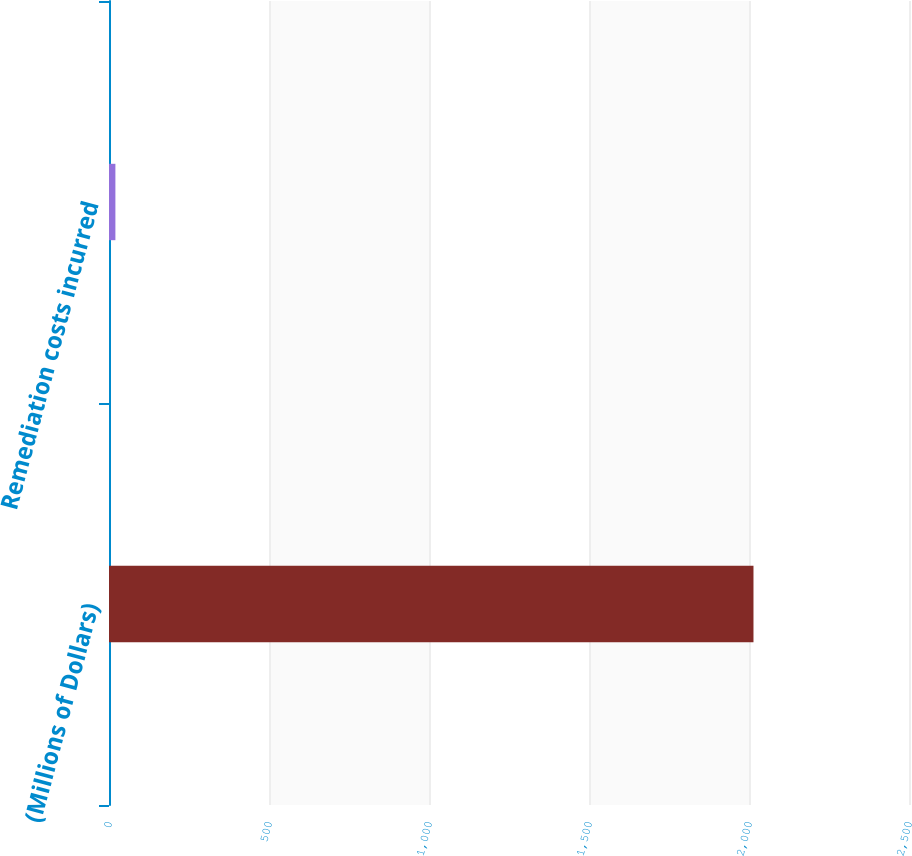<chart> <loc_0><loc_0><loc_500><loc_500><bar_chart><fcel>(Millions of Dollars)<fcel>Remediation costs incurred<nl><fcel>2014<fcel>20<nl></chart> 